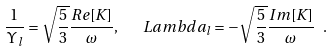Convert formula to latex. <formula><loc_0><loc_0><loc_500><loc_500>\frac { 1 } { \Upsilon _ { l } } = \sqrt { \frac { 5 } { 3 } } \frac { R e [ K ] } { \omega } , \ \ \ L a m b d a _ { l } = - \sqrt { \frac { 5 } { 3 } } \frac { I m [ K ] } { \omega } \ .</formula> 